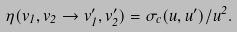<formula> <loc_0><loc_0><loc_500><loc_500>\eta ( { v } _ { 1 } , { v } _ { 2 } \to { v } _ { 1 } ^ { \prime } , { v } _ { 2 } ^ { \prime } ) = \sigma _ { c } ( { u } , { u } ^ { \prime } ) / u ^ { 2 } .</formula> 